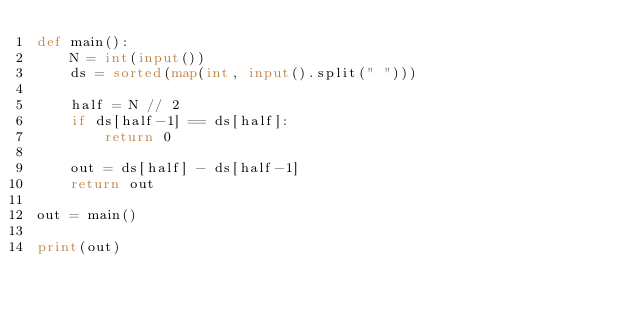<code> <loc_0><loc_0><loc_500><loc_500><_Python_>def main():
    N = int(input())
    ds = sorted(map(int, input().split(" ")))

    half = N // 2
    if ds[half-1] == ds[half]:
        return 0

    out = ds[half] - ds[half-1]
    return out

out = main()

print(out)</code> 